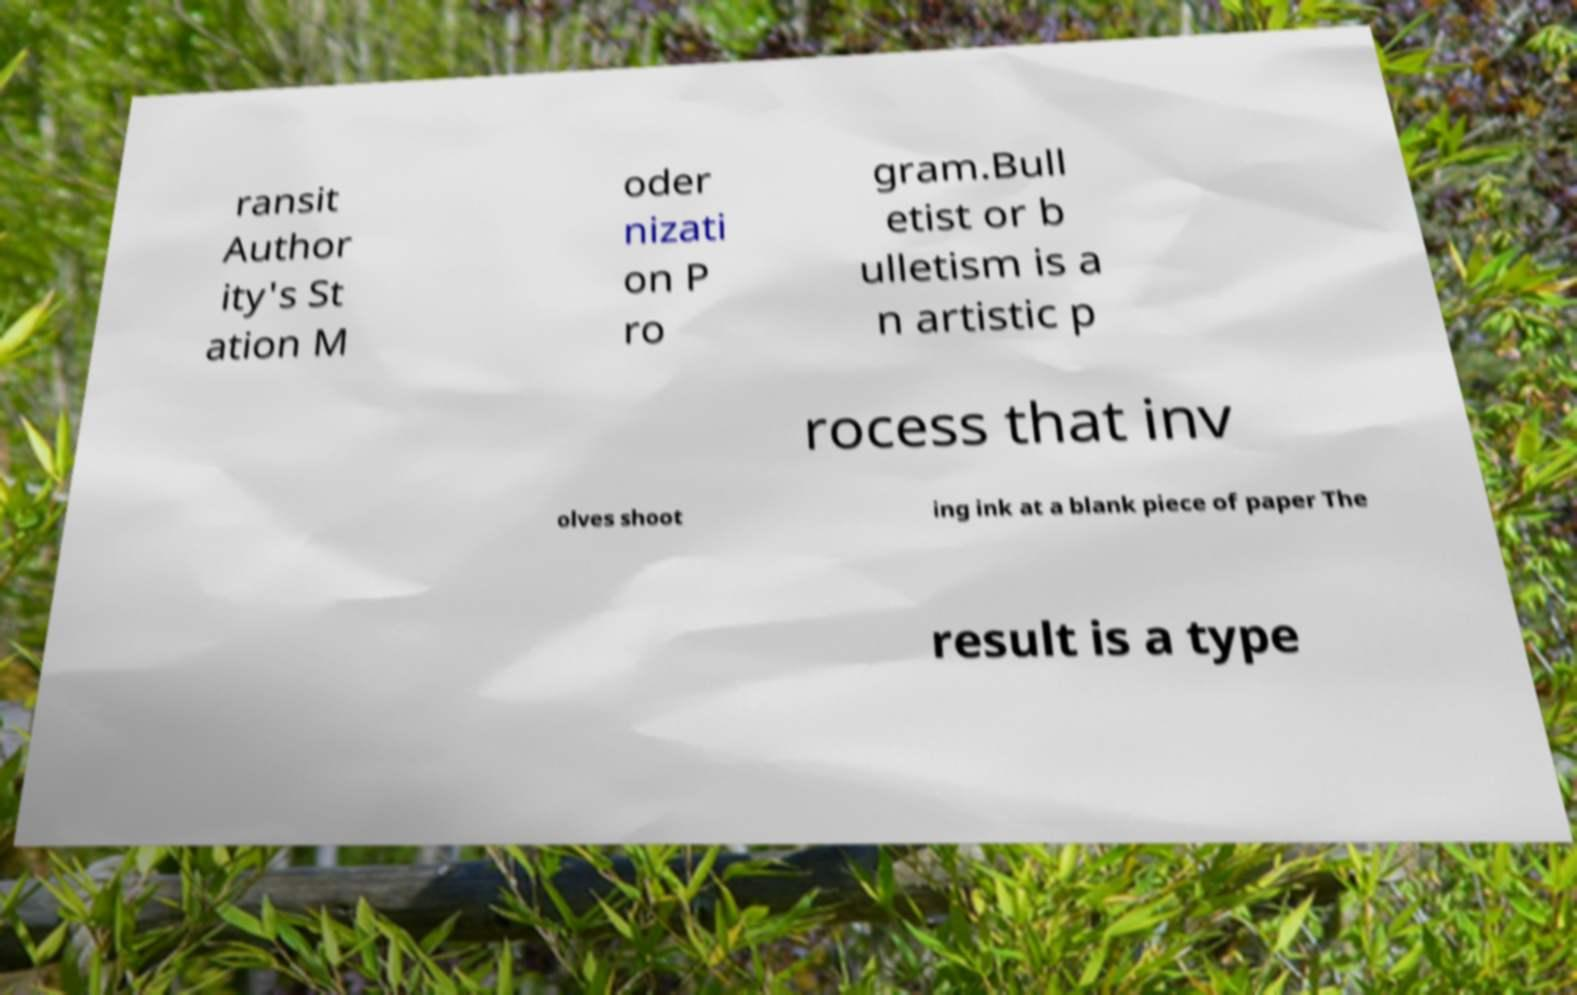Could you extract and type out the text from this image? ransit Author ity's St ation M oder nizati on P ro gram.Bull etist or b ulletism is a n artistic p rocess that inv olves shoot ing ink at a blank piece of paper The result is a type 